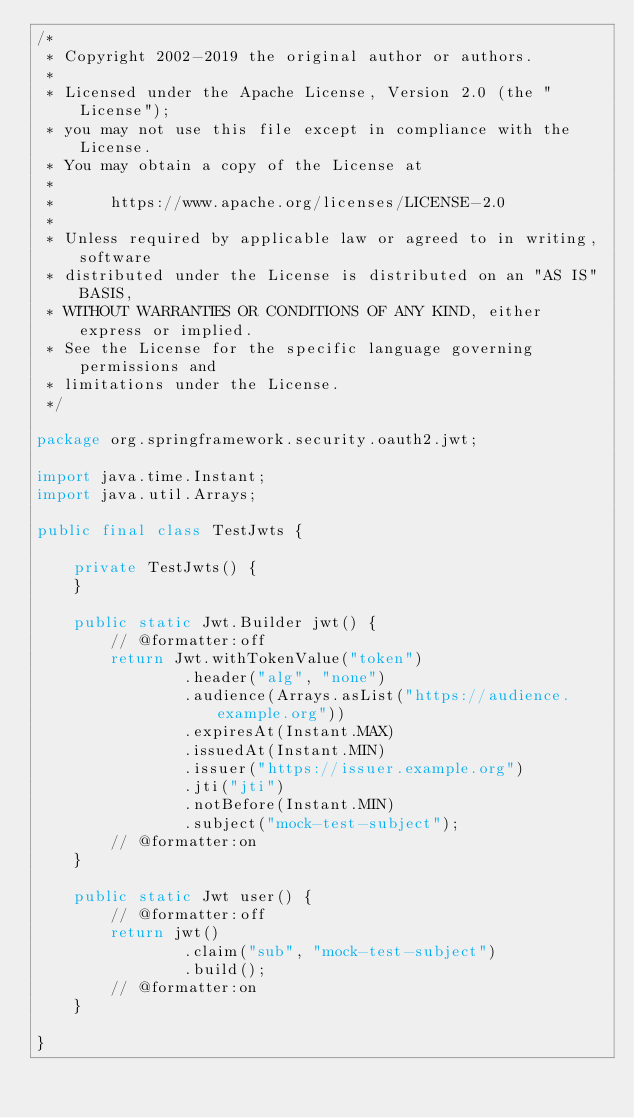<code> <loc_0><loc_0><loc_500><loc_500><_Java_>/*
 * Copyright 2002-2019 the original author or authors.
 *
 * Licensed under the Apache License, Version 2.0 (the "License");
 * you may not use this file except in compliance with the License.
 * You may obtain a copy of the License at
 *
 *      https://www.apache.org/licenses/LICENSE-2.0
 *
 * Unless required by applicable law or agreed to in writing, software
 * distributed under the License is distributed on an "AS IS" BASIS,
 * WITHOUT WARRANTIES OR CONDITIONS OF ANY KIND, either express or implied.
 * See the License for the specific language governing permissions and
 * limitations under the License.
 */

package org.springframework.security.oauth2.jwt;

import java.time.Instant;
import java.util.Arrays;

public final class TestJwts {

	private TestJwts() {
	}

	public static Jwt.Builder jwt() {
		// @formatter:off
		return Jwt.withTokenValue("token")
				.header("alg", "none")
				.audience(Arrays.asList("https://audience.example.org"))
				.expiresAt(Instant.MAX)
				.issuedAt(Instant.MIN)
				.issuer("https://issuer.example.org")
				.jti("jti")
				.notBefore(Instant.MIN)
				.subject("mock-test-subject");
		// @formatter:on
	}

	public static Jwt user() {
		// @formatter:off
		return jwt()
				.claim("sub", "mock-test-subject")
				.build();
		// @formatter:on
	}

}
</code> 